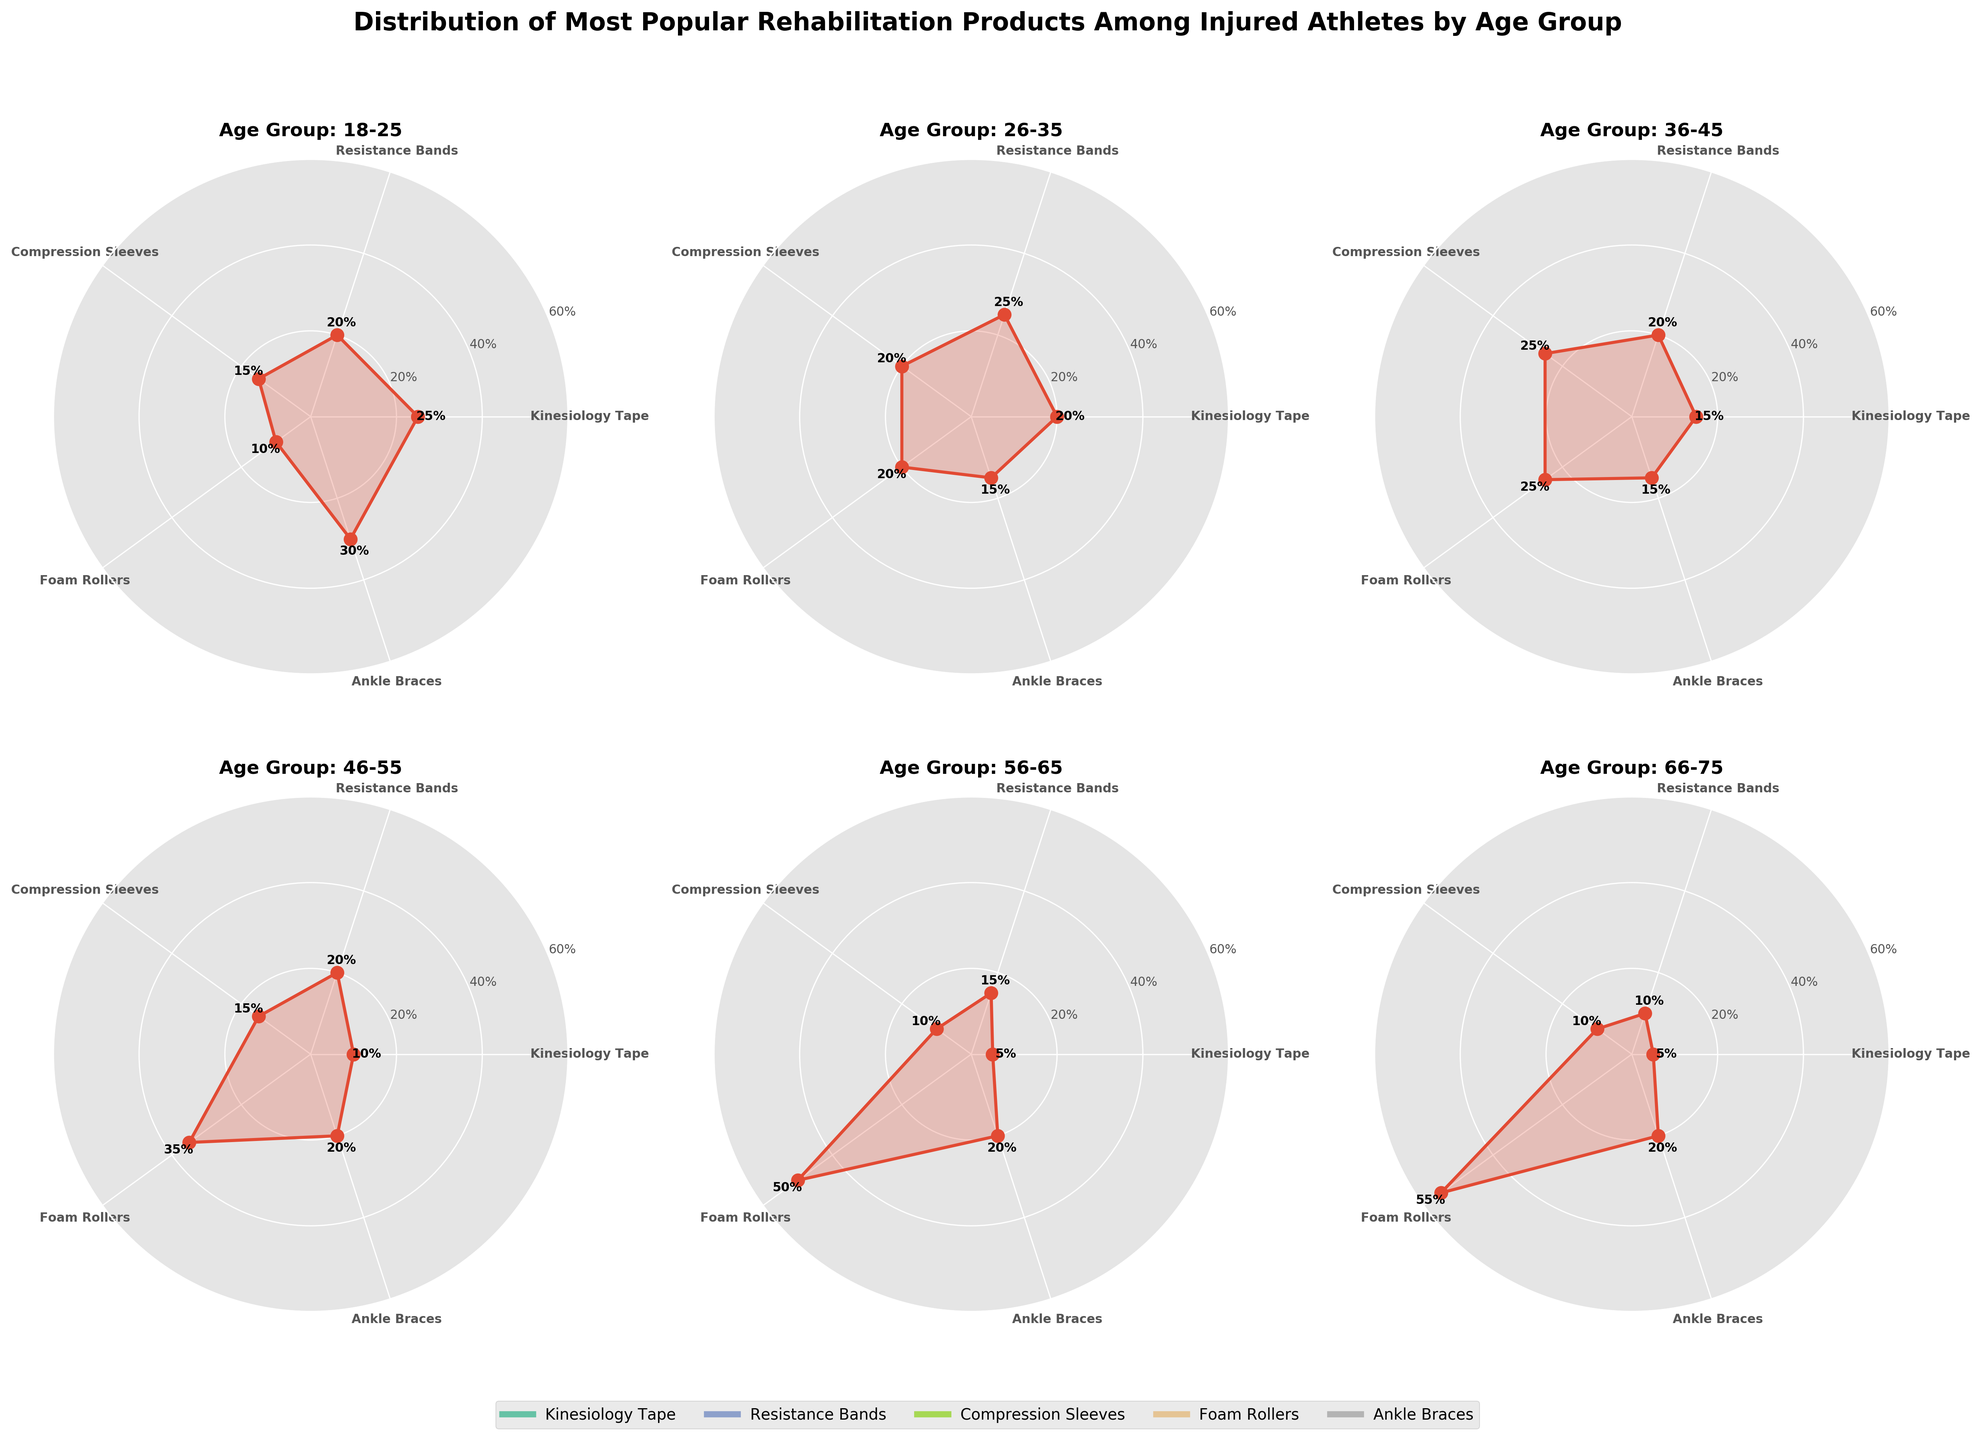Which age group has the highest preference for foam rollers? By examining each subplot, the age group 66-75 has the highest values for foam rollers, with a preference percentage reaching 55%.
Answer: 66-75 What is the most popular rehabilitation product among athletes aged 18-25? The subplot titled "Age Group: 18-25" shows the highest value for ankle braces, reaching a 30% popularity percentage, which is higher than any other product in this group.
Answer: Ankle Braces How does the popularity of kinesiology tape change as age increases from 18-25 to 66-75? Kinesiology tape starts with a 25% popularity in the 18-25 age group and gradually decreases through each subsequent age group, reaching 5% in the 56-65 and 66-75 age groups.
Answer: It decreases Which rehabilitation product is equally popular among athletes aged 26-35 and 46-55? By comparing the subplots for the 26-35 and 46-55 age groups, resistance bands have the same popularity percentage of 20% in both age groups.
Answer: Resistance Bands What product has a 50% popularity among athletes aged 56-65? The subplot titled "Age Group: 56-65" shows that foam rollers have a 50% popularity, which is the highest for that age group.
Answer: Foam Rollers Between compression sleeves and ankle braces, which is more popular among athletes aged 36-45? The subplot for the age group 36-45 shows that compression sleeves have a 25% popularity, while ankle braces have a 15% popularity. Hence, compression sleeves are more popular.
Answer: Compression Sleeves How many products have a popularity percentage above 20% in the 46-55 age group? In the subplot for the 46-55 age group, only foam rollers (35%) and ankle braces (20%) exceed 20%. The rest of the products are below 20%.
Answer: 2 Which age group shows the highest variance in the popularity of rehabilitation products? By visually inspecting the difference between the highest and lowest values for each subplot, the age group 66-75 shows the highest variance (55% for foam rollers and 5% for kinesiology tape).
Answer: 66-75 